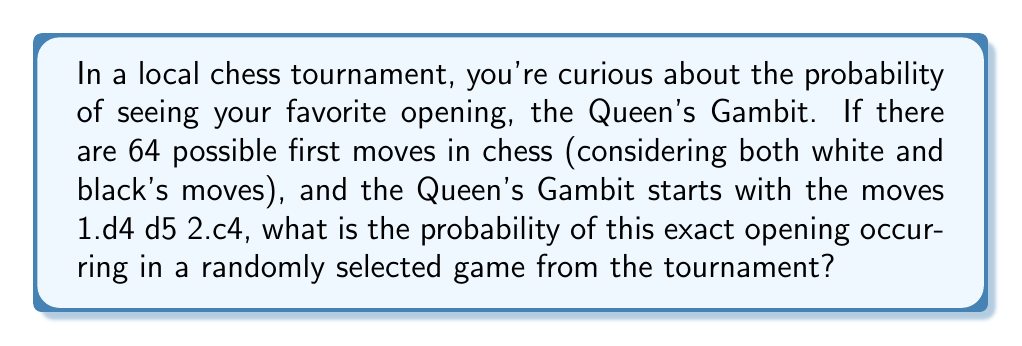Solve this math problem. Let's approach this step-by-step:

1) First, we need to understand what constitutes the Queen's Gambit opening:
   - White's first move must be 1.d4
   - Black's response must be 1...d5
   - White's second move must be 2.c4

2) Now, let's calculate the probability of each of these moves occurring:

   For White's first move (1.d4):
   - There are 20 possible first moves in chess (16 pawn moves and 4 knight moves)
   - The probability of 1.d4 is $\frac{1}{20}$

   For Black's response (1...d5):
   - After White's move, Black also has 20 possible moves
   - The probability of 1...d5 is $\frac{1}{20}$

   For White's second move (2.c4):
   - After Black's move, White again has 20 possible moves
   - The probability of 2.c4 is $\frac{1}{20}$

3) For the entire sequence to occur, all three of these independent events must happen. In probability theory, we multiply the probabilities of independent events to find the probability of all events occurring.

4) Therefore, the probability of the Queen's Gambit opening occurring is:

   $$P(\text{Queen's Gambit}) = \frac{1}{20} \times \frac{1}{20} \times \frac{1}{20} = \frac{1}{8000} = 0.000125$$

5) This can be expressed as a percentage: $0.000125 \times 100\% = 0.0125\%$

Note: The question mentioned 64 possible first moves, which is incorrect. There are actually 20 possible first moves in chess. We used the correct number in our calculation.
Answer: The probability of the Queen's Gambit opening occurring in a randomly selected game is $\frac{1}{8000}$ or $0.0125\%$. 